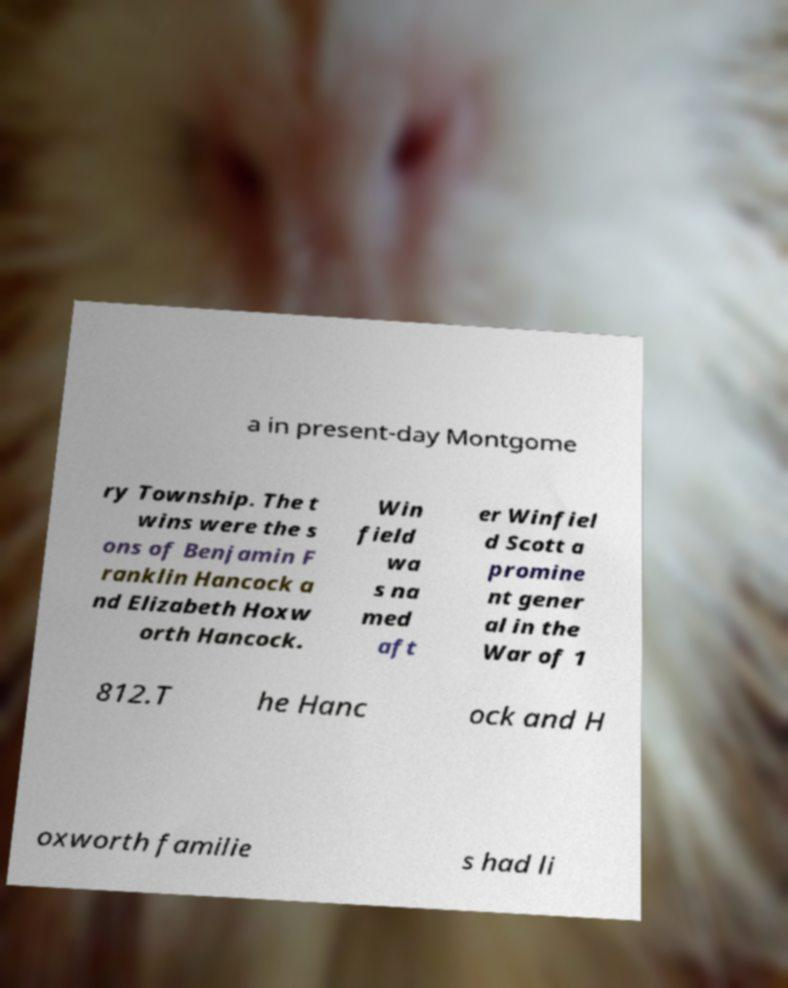I need the written content from this picture converted into text. Can you do that? a in present-day Montgome ry Township. The t wins were the s ons of Benjamin F ranklin Hancock a nd Elizabeth Hoxw orth Hancock. Win field wa s na med aft er Winfiel d Scott a promine nt gener al in the War of 1 812.T he Hanc ock and H oxworth familie s had li 